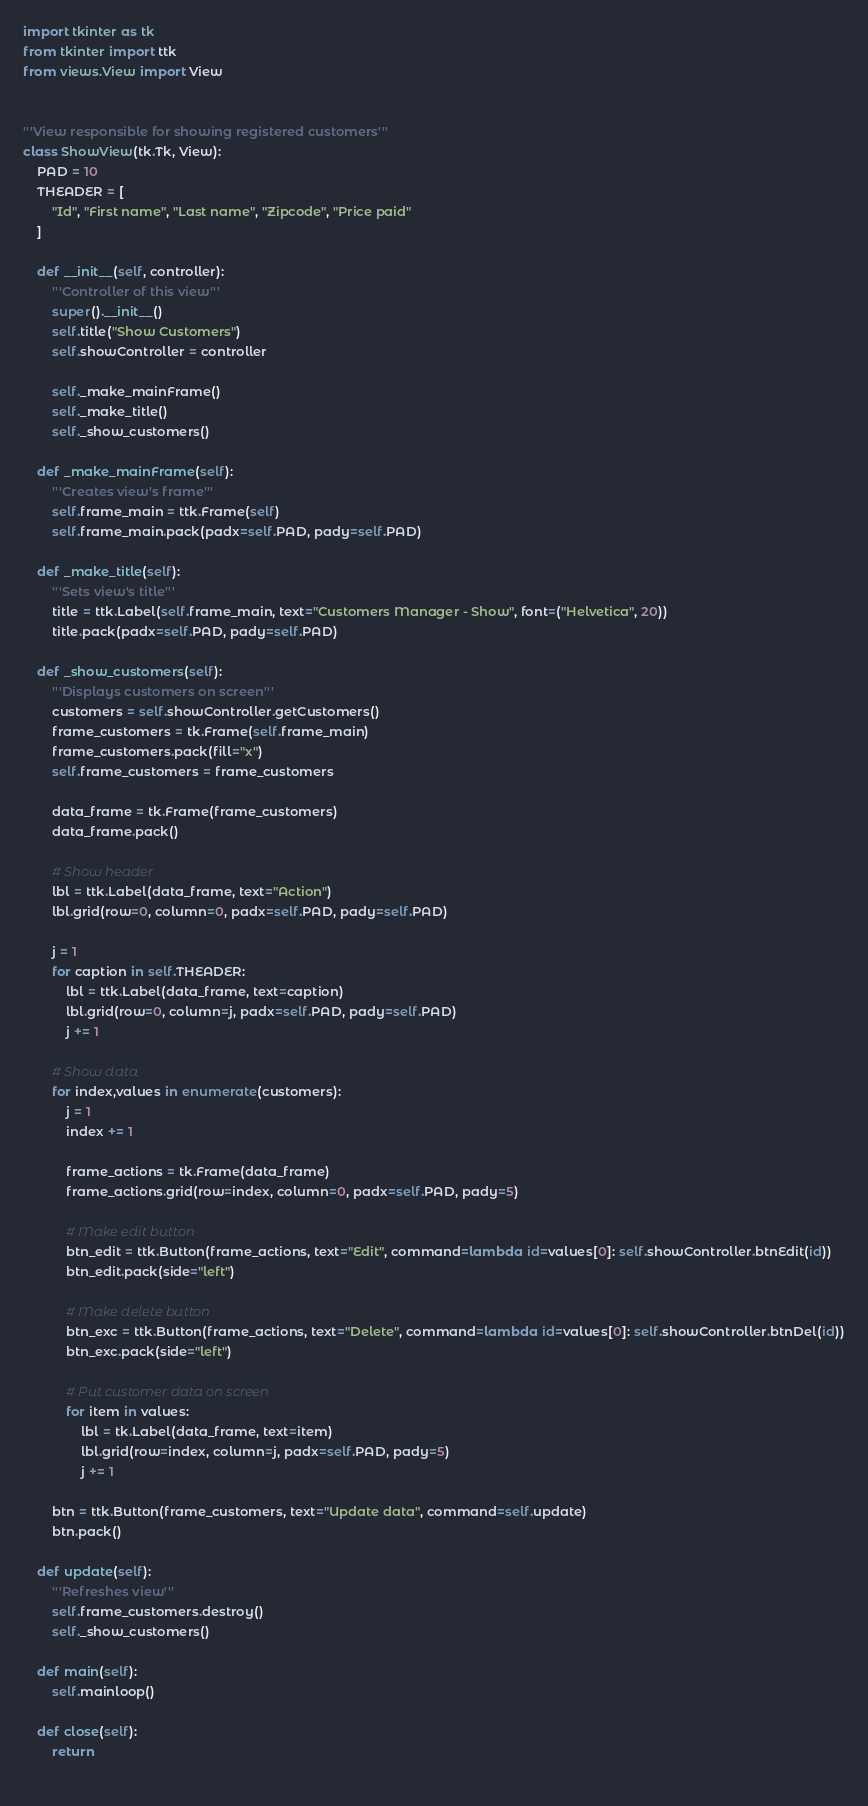Convert code to text. <code><loc_0><loc_0><loc_500><loc_500><_Python_>import tkinter as tk
from tkinter import ttk
from views.View import View


'''View responsible for showing registered customers'''
class ShowView(tk.Tk, View):
    PAD = 10
    THEADER = [
        "Id", "First name", "Last name", "Zipcode", "Price paid" 
    ]

    def __init__(self, controller):
        '''Controller of this view'''
        super().__init__()
        self.title("Show Customers")
        self.showController = controller
    
        self._make_mainFrame()
        self._make_title()
        self._show_customers()
    
    def _make_mainFrame(self):
        '''Creates view's frame'''
        self.frame_main = ttk.Frame(self)
        self.frame_main.pack(padx=self.PAD, pady=self.PAD)
        
    def _make_title(self):
        '''Sets view's title'''
        title = ttk.Label(self.frame_main, text="Customers Manager - Show", font=("Helvetica", 20))
        title.pack(padx=self.PAD, pady=self.PAD)
    
    def _show_customers(self):
        '''Displays customers on screen'''
        customers = self.showController.getCustomers()
        frame_customers = tk.Frame(self.frame_main)
        frame_customers.pack(fill="x")
        self.frame_customers = frame_customers
        
        data_frame = tk.Frame(frame_customers)
        data_frame.pack()
        
        # Show header
        lbl = ttk.Label(data_frame, text="Action")
        lbl.grid(row=0, column=0, padx=self.PAD, pady=self.PAD)
        
        j = 1
        for caption in self.THEADER:
            lbl = ttk.Label(data_frame, text=caption)
            lbl.grid(row=0, column=j, padx=self.PAD, pady=self.PAD)
            j += 1
        
        # Show data
        for index,values in enumerate(customers):
            j = 1
            index += 1
            
            frame_actions = tk.Frame(data_frame)
            frame_actions.grid(row=index, column=0, padx=self.PAD, pady=5)
            
            # Make edit button
            btn_edit = ttk.Button(frame_actions, text="Edit", command=lambda id=values[0]: self.showController.btnEdit(id))
            btn_edit.pack(side="left")
            
            # Make delete button
            btn_exc = ttk.Button(frame_actions, text="Delete", command=lambda id=values[0]: self.showController.btnDel(id))
            btn_exc.pack(side="left")
            
            # Put customer data on screen
            for item in values:
                lbl = tk.Label(data_frame, text=item)
                lbl.grid(row=index, column=j, padx=self.PAD, pady=5)
                j += 1
        
        btn = ttk.Button(frame_customers, text="Update data", command=self.update)
        btn.pack()

    def update(self):
        '''Refreshes view'''
        self.frame_customers.destroy()
        self._show_customers()

    def main(self):
        self.mainloop()

    def close(self):
        return
        </code> 